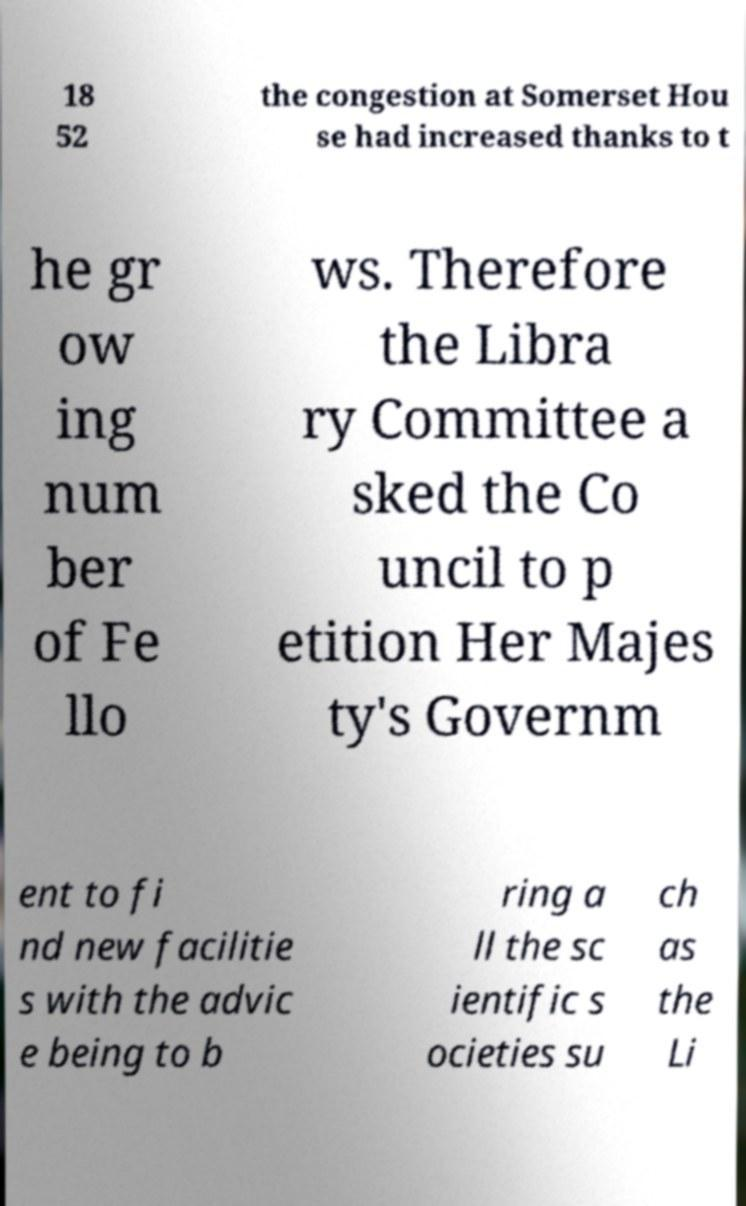There's text embedded in this image that I need extracted. Can you transcribe it verbatim? 18 52 the congestion at Somerset Hou se had increased thanks to t he gr ow ing num ber of Fe llo ws. Therefore the Libra ry Committee a sked the Co uncil to p etition Her Majes ty's Governm ent to fi nd new facilitie s with the advic e being to b ring a ll the sc ientific s ocieties su ch as the Li 